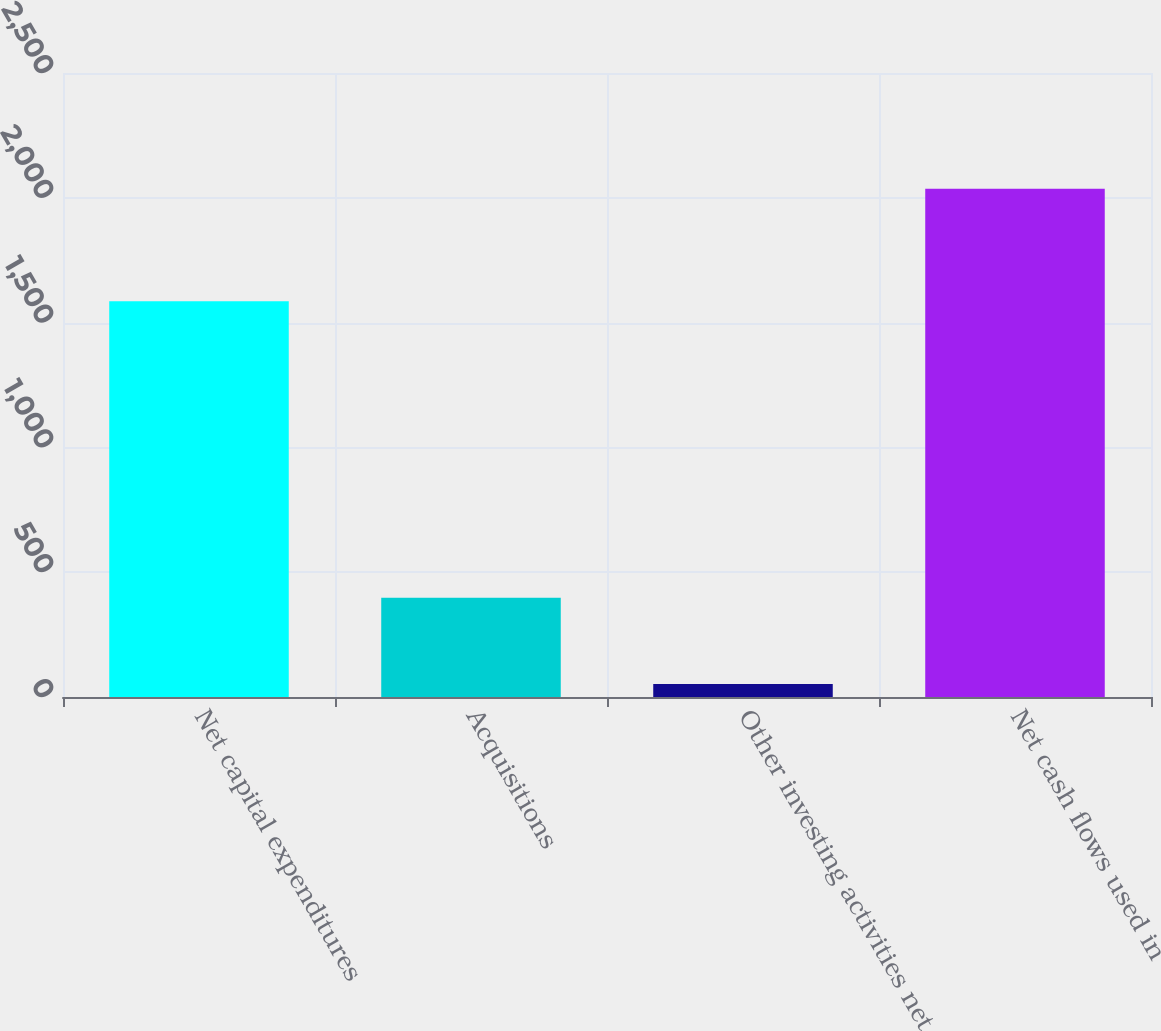<chart> <loc_0><loc_0><loc_500><loc_500><bar_chart><fcel>Net capital expenditures<fcel>Acquisitions<fcel>Other investing activities net<fcel>Net cash flows used in<nl><fcel>1586<fcel>398<fcel>52<fcel>2036<nl></chart> 